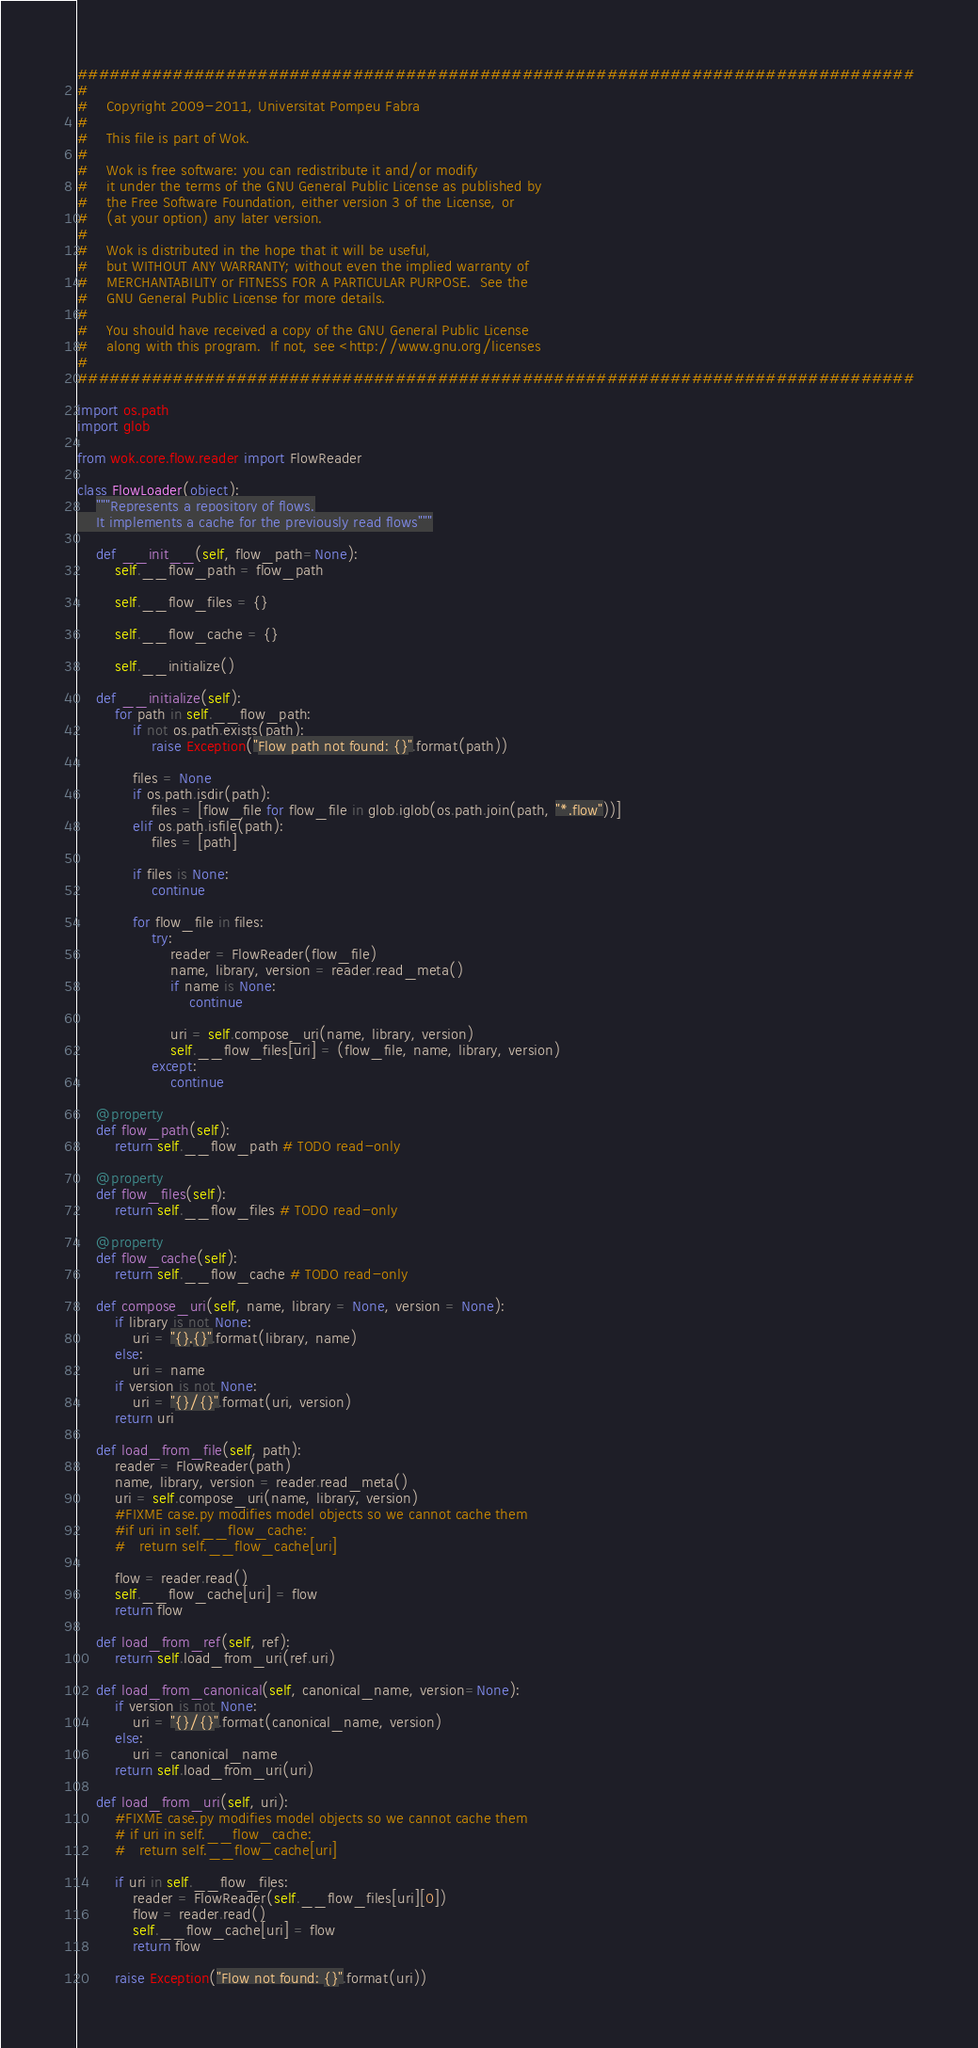Convert code to text. <code><loc_0><loc_0><loc_500><loc_500><_Python_>###############################################################################
#
#    Copyright 2009-2011, Universitat Pompeu Fabra
#
#    This file is part of Wok.
#
#    Wok is free software: you can redistribute it and/or modify
#    it under the terms of the GNU General Public License as published by
#    the Free Software Foundation, either version 3 of the License, or
#    (at your option) any later version.
#
#    Wok is distributed in the hope that it will be useful,
#    but WITHOUT ANY WARRANTY; without even the implied warranty of
#    MERCHANTABILITY or FITNESS FOR A PARTICULAR PURPOSE.  See the
#    GNU General Public License for more details.
#
#    You should have received a copy of the GNU General Public License
#    along with this program.  If not, see <http://www.gnu.org/licenses
#
###############################################################################

import os.path
import glob

from wok.core.flow.reader import FlowReader

class FlowLoader(object):
	"""Represents a repository of flows.
	It implements a cache for the previously read flows"""

	def __init__(self, flow_path=None):
		self.__flow_path = flow_path

		self.__flow_files = {}

		self.__flow_cache = {}

		self.__initialize()

	def __initialize(self):
		for path in self.__flow_path:
			if not os.path.exists(path):
				raise Exception("Flow path not found: {}".format(path))

			files = None
			if os.path.isdir(path):
				files = [flow_file for flow_file in glob.iglob(os.path.join(path, "*.flow"))]
			elif os.path.isfile(path):
				files = [path]

			if files is None:
				continue

			for flow_file in files:
				try:
					reader = FlowReader(flow_file)
					name, library, version = reader.read_meta()
					if name is None:
						continue

					uri = self.compose_uri(name, library, version)
					self.__flow_files[uri] = (flow_file, name, library, version)
				except:
					continue

	@property
	def flow_path(self):
		return self.__flow_path # TODO read-only

	@property
	def flow_files(self):
		return self.__flow_files # TODO read-only

	@property
	def flow_cache(self):
		return self.__flow_cache # TODO read-only

	def compose_uri(self, name, library = None, version = None):
		if library is not None:
			uri = "{}.{}".format(library, name)
		else:
			uri = name
		if version is not None:
			uri = "{}/{}".format(uri, version)
		return uri

	def load_from_file(self, path):
		reader = FlowReader(path)
		name, library, version = reader.read_meta()
		uri = self.compose_uri(name, library, version)
		#FIXME case.py modifies model objects so we cannot cache them
		#if uri in self.__flow_cache:
		#	return self.__flow_cache[uri]

		flow = reader.read()
		self.__flow_cache[uri] = flow
		return flow

	def load_from_ref(self, ref):
		return self.load_from_uri(ref.uri)

	def load_from_canonical(self, canonical_name, version=None):
		if version is not None:
			uri = "{}/{}".format(canonical_name, version)
		else:
			uri = canonical_name
		return self.load_from_uri(uri)

	def load_from_uri(self, uri):
		#FIXME case.py modifies model objects so we cannot cache them
		# if uri in self.__flow_cache:
		#	return self.__flow_cache[uri]

		if uri in self.__flow_files:
			reader = FlowReader(self.__flow_files[uri][0])
			flow = reader.read()
			self.__flow_cache[uri] = flow
			return flow

		raise Exception("Flow not found: {}".format(uri))
</code> 